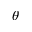Convert formula to latex. <formula><loc_0><loc_0><loc_500><loc_500>\theta</formula> 